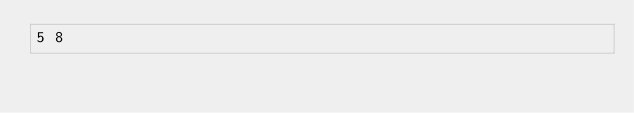<code> <loc_0><loc_0><loc_500><loc_500><_C#_>5 8</code> 